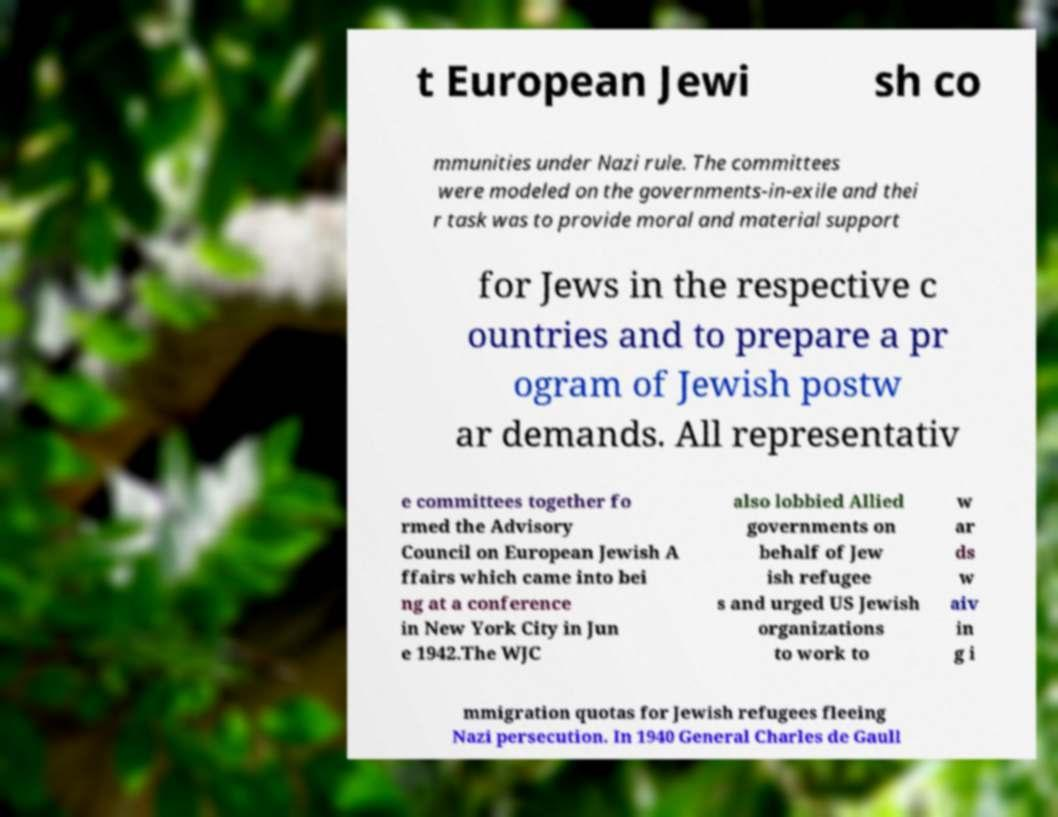Can you accurately transcribe the text from the provided image for me? t European Jewi sh co mmunities under Nazi rule. The committees were modeled on the governments-in-exile and thei r task was to provide moral and material support for Jews in the respective c ountries and to prepare a pr ogram of Jewish postw ar demands. All representativ e committees together fo rmed the Advisory Council on European Jewish A ffairs which came into bei ng at a conference in New York City in Jun e 1942.The WJC also lobbied Allied governments on behalf of Jew ish refugee s and urged US Jewish organizations to work to w ar ds w aiv in g i mmigration quotas for Jewish refugees fleeing Nazi persecution. In 1940 General Charles de Gaull 